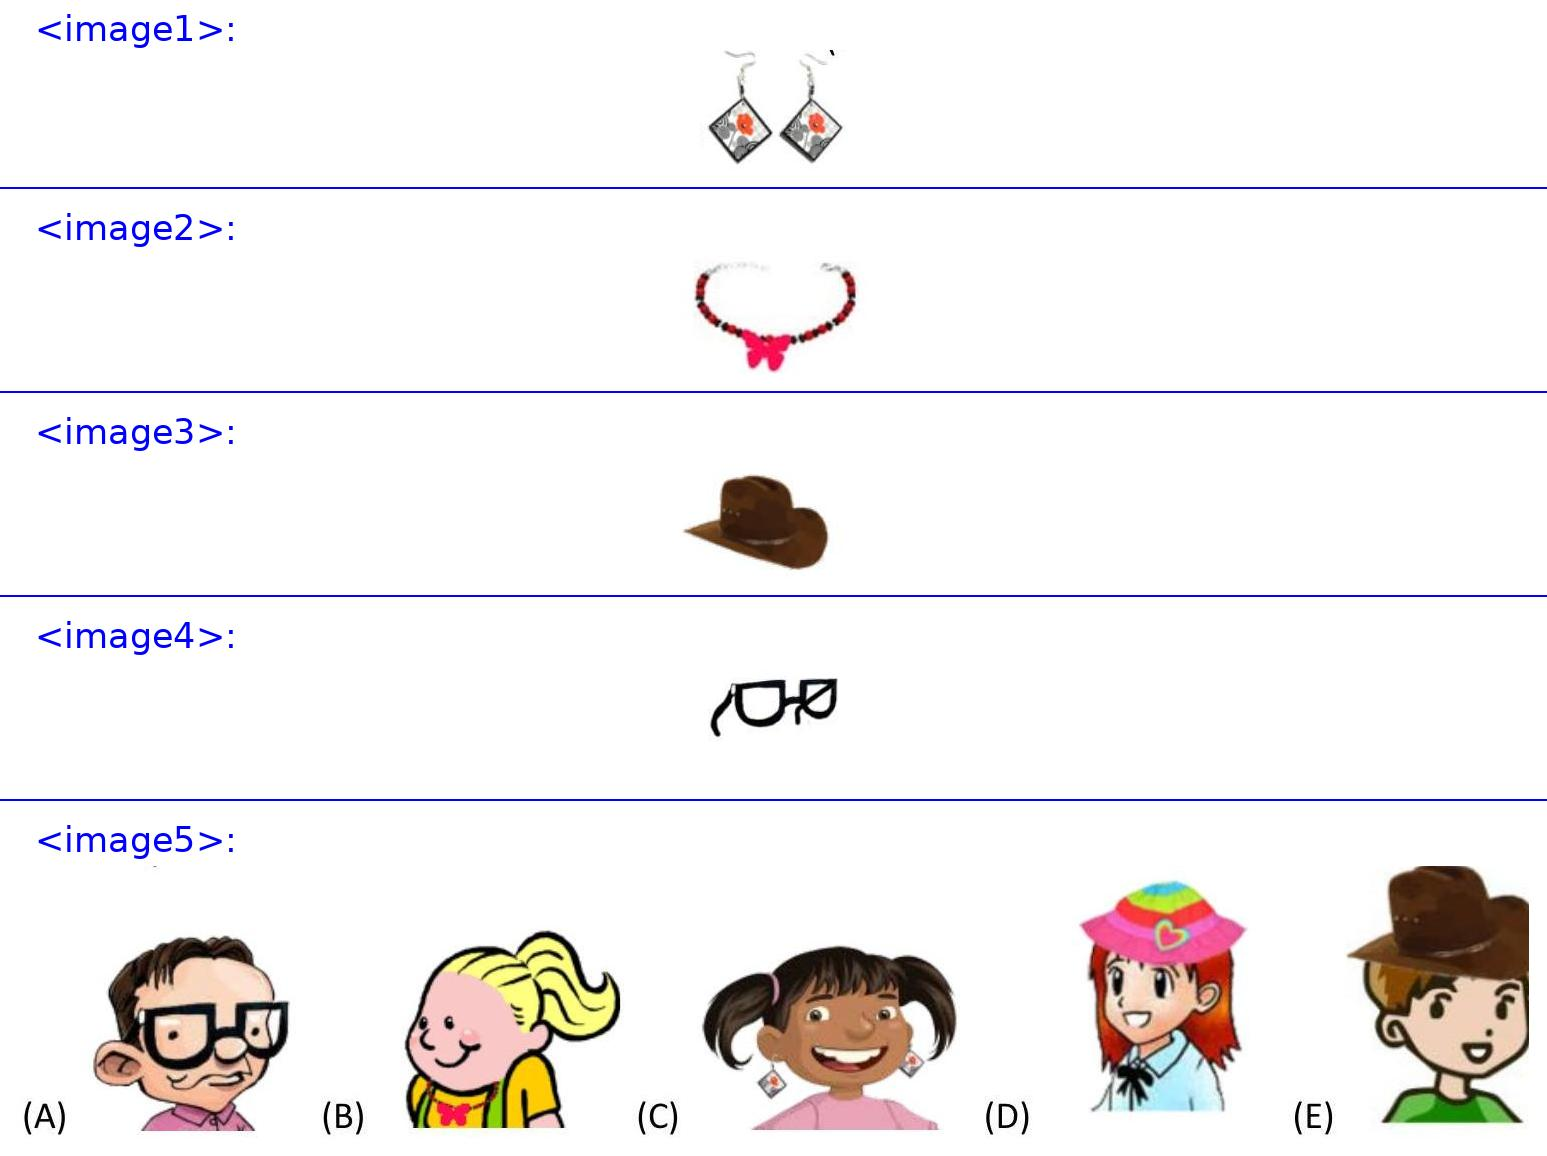<image3> Why might Josef choose to wear this hat? Josef might wear this brown hat because it's often associated with a rugged and outdoorsy style, which could imply he enjoys activities such as hiking or farming. The hat’s wide brim offers practical benefits like sun protection, enhancing its utility. 